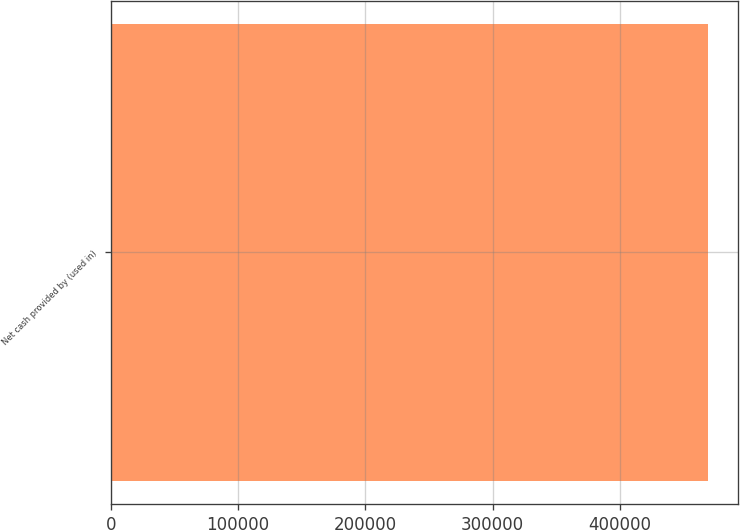Convert chart to OTSL. <chart><loc_0><loc_0><loc_500><loc_500><bar_chart><fcel>Net cash provided by (used in)<nl><fcel>469438<nl></chart> 